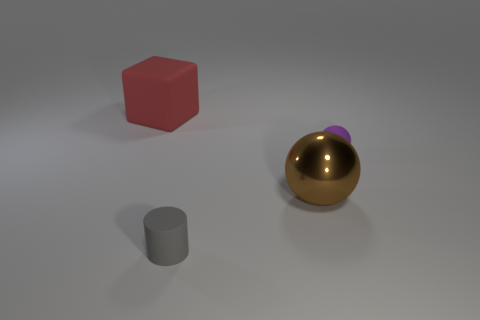Subtract 1 cubes. How many cubes are left? 0 Add 3 big brown metal things. How many objects exist? 7 Subtract all brown spheres. How many spheres are left? 1 Subtract all cyan cubes. Subtract all brown cylinders. How many cubes are left? 1 Subtract all brown cylinders. How many brown spheres are left? 1 Subtract all big cyan spheres. Subtract all small matte objects. How many objects are left? 2 Add 3 cylinders. How many cylinders are left? 4 Add 3 cylinders. How many cylinders exist? 4 Subtract 0 red spheres. How many objects are left? 4 Subtract all blocks. How many objects are left? 3 